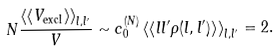Convert formula to latex. <formula><loc_0><loc_0><loc_500><loc_500>N \frac { \left \langle \left \langle V _ { \text {excl} } \right \rangle \right \rangle _ { l , l ^ { \prime } } } { V } \sim c _ { 0 } ^ { ( N ) } \left \langle \left \langle l l ^ { \prime } \rho ( l , l ^ { \prime } ) \right \rangle \right \rangle _ { l , l ^ { \prime } } = 2 .</formula> 